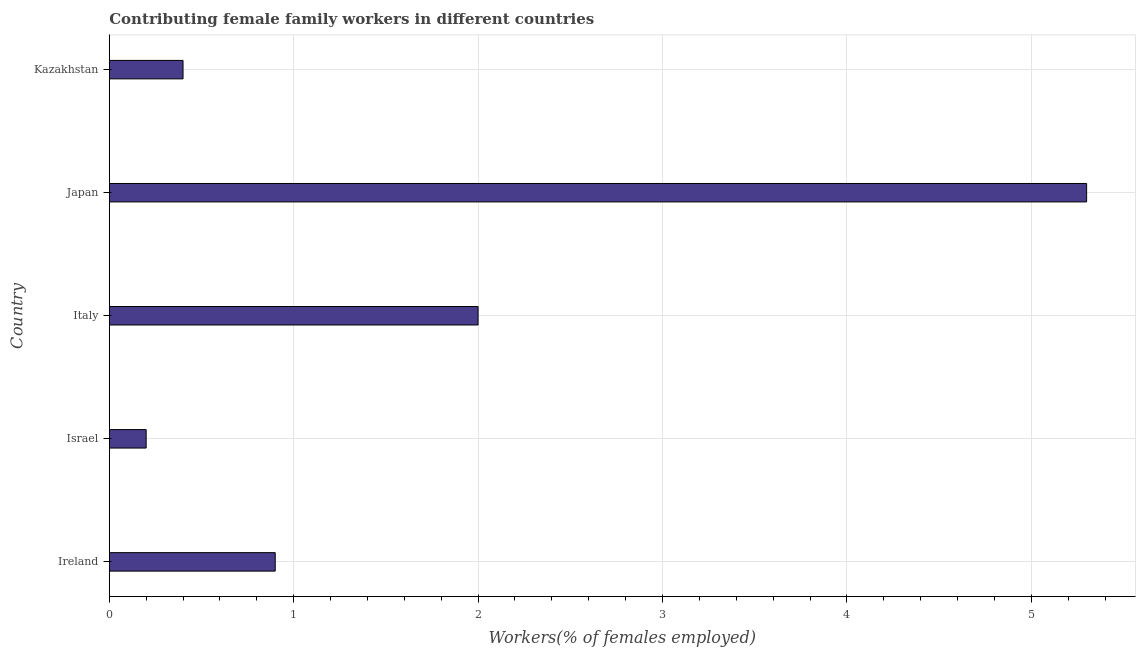What is the title of the graph?
Provide a short and direct response. Contributing female family workers in different countries. What is the label or title of the X-axis?
Your response must be concise. Workers(% of females employed). What is the label or title of the Y-axis?
Give a very brief answer. Country. What is the contributing female family workers in Japan?
Keep it short and to the point. 5.3. Across all countries, what is the maximum contributing female family workers?
Give a very brief answer. 5.3. Across all countries, what is the minimum contributing female family workers?
Keep it short and to the point. 0.2. In which country was the contributing female family workers maximum?
Your response must be concise. Japan. In which country was the contributing female family workers minimum?
Make the answer very short. Israel. What is the sum of the contributing female family workers?
Your response must be concise. 8.8. What is the average contributing female family workers per country?
Provide a succinct answer. 1.76. What is the median contributing female family workers?
Provide a succinct answer. 0.9. In how many countries, is the contributing female family workers greater than 2.4 %?
Give a very brief answer. 1. What is the ratio of the contributing female family workers in Ireland to that in Japan?
Keep it short and to the point. 0.17. Are all the bars in the graph horizontal?
Provide a short and direct response. Yes. What is the Workers(% of females employed) in Ireland?
Your response must be concise. 0.9. What is the Workers(% of females employed) of Israel?
Make the answer very short. 0.2. What is the Workers(% of females employed) in Italy?
Give a very brief answer. 2. What is the Workers(% of females employed) of Japan?
Offer a terse response. 5.3. What is the Workers(% of females employed) in Kazakhstan?
Your answer should be compact. 0.4. What is the difference between the Workers(% of females employed) in Ireland and Israel?
Your answer should be compact. 0.7. What is the difference between the Workers(% of females employed) in Ireland and Italy?
Provide a short and direct response. -1.1. What is the difference between the Workers(% of females employed) in Ireland and Japan?
Offer a very short reply. -4.4. What is the difference between the Workers(% of females employed) in Israel and Italy?
Offer a very short reply. -1.8. What is the difference between the Workers(% of females employed) in Israel and Japan?
Offer a terse response. -5.1. What is the difference between the Workers(% of females employed) in Israel and Kazakhstan?
Your answer should be compact. -0.2. What is the difference between the Workers(% of females employed) in Japan and Kazakhstan?
Your answer should be compact. 4.9. What is the ratio of the Workers(% of females employed) in Ireland to that in Israel?
Provide a short and direct response. 4.5. What is the ratio of the Workers(% of females employed) in Ireland to that in Italy?
Give a very brief answer. 0.45. What is the ratio of the Workers(% of females employed) in Ireland to that in Japan?
Keep it short and to the point. 0.17. What is the ratio of the Workers(% of females employed) in Ireland to that in Kazakhstan?
Give a very brief answer. 2.25. What is the ratio of the Workers(% of females employed) in Israel to that in Italy?
Offer a very short reply. 0.1. What is the ratio of the Workers(% of females employed) in Israel to that in Japan?
Keep it short and to the point. 0.04. What is the ratio of the Workers(% of females employed) in Israel to that in Kazakhstan?
Your response must be concise. 0.5. What is the ratio of the Workers(% of females employed) in Italy to that in Japan?
Provide a succinct answer. 0.38. What is the ratio of the Workers(% of females employed) in Japan to that in Kazakhstan?
Give a very brief answer. 13.25. 